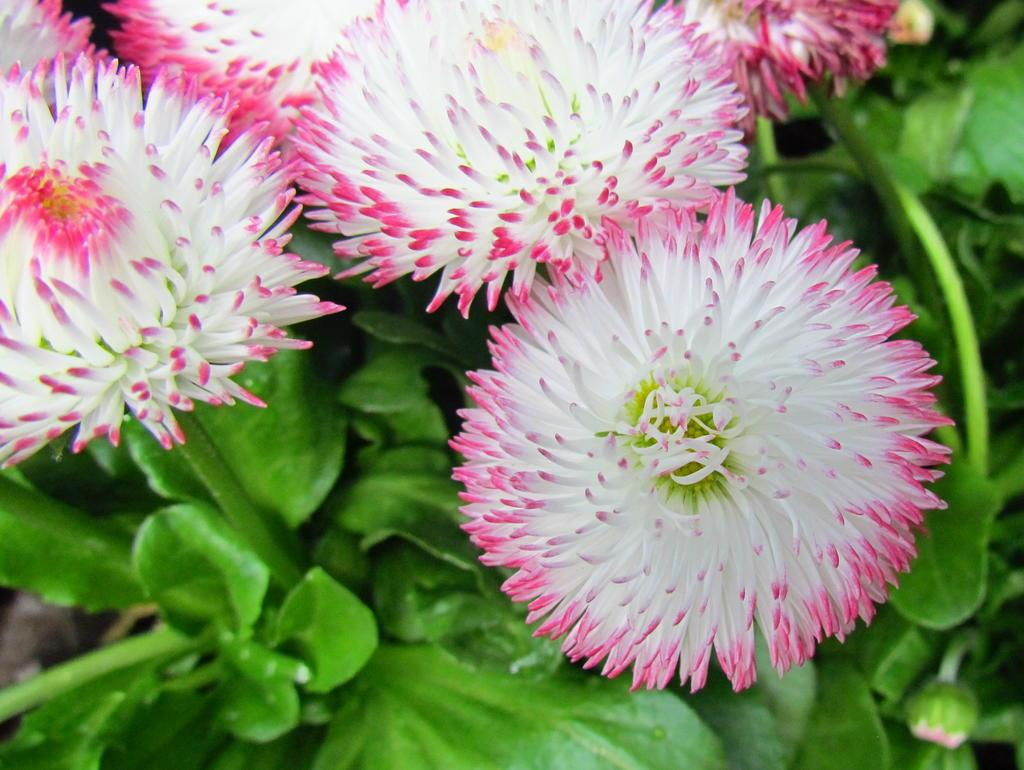What type of plants are in the image? There are flowers in the image. Can you describe the stage of growth of the flowers? There is a bud on the plant in the image. What colors can be seen in the flowers? The flowers are in white and pink color. How does the sand affect the growth of the flowers in the image? There is no sand present in the image, so it does not affect the growth of the flowers. 